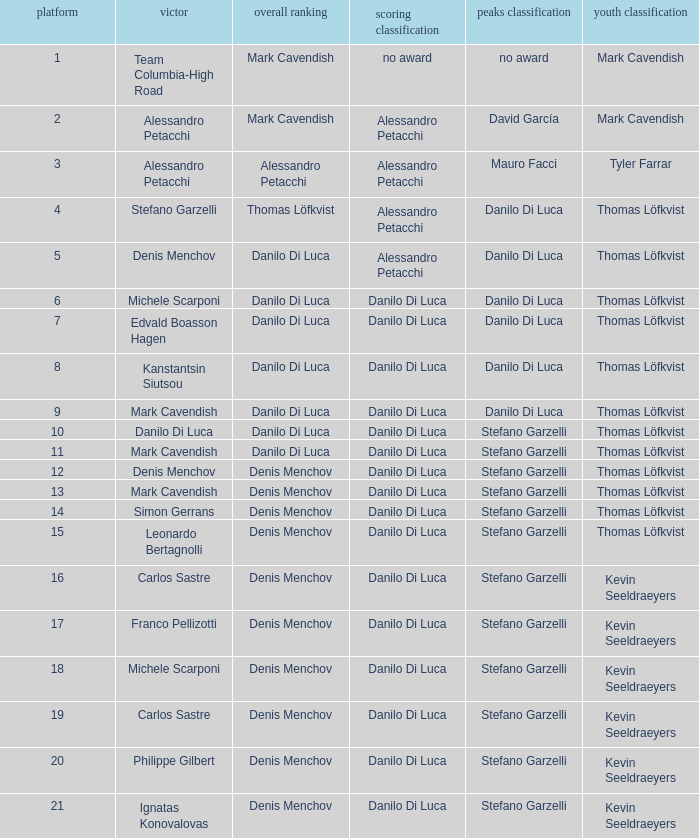In the event of philippe gilbert's victory, who claims the points classification? Danilo Di Luca. 